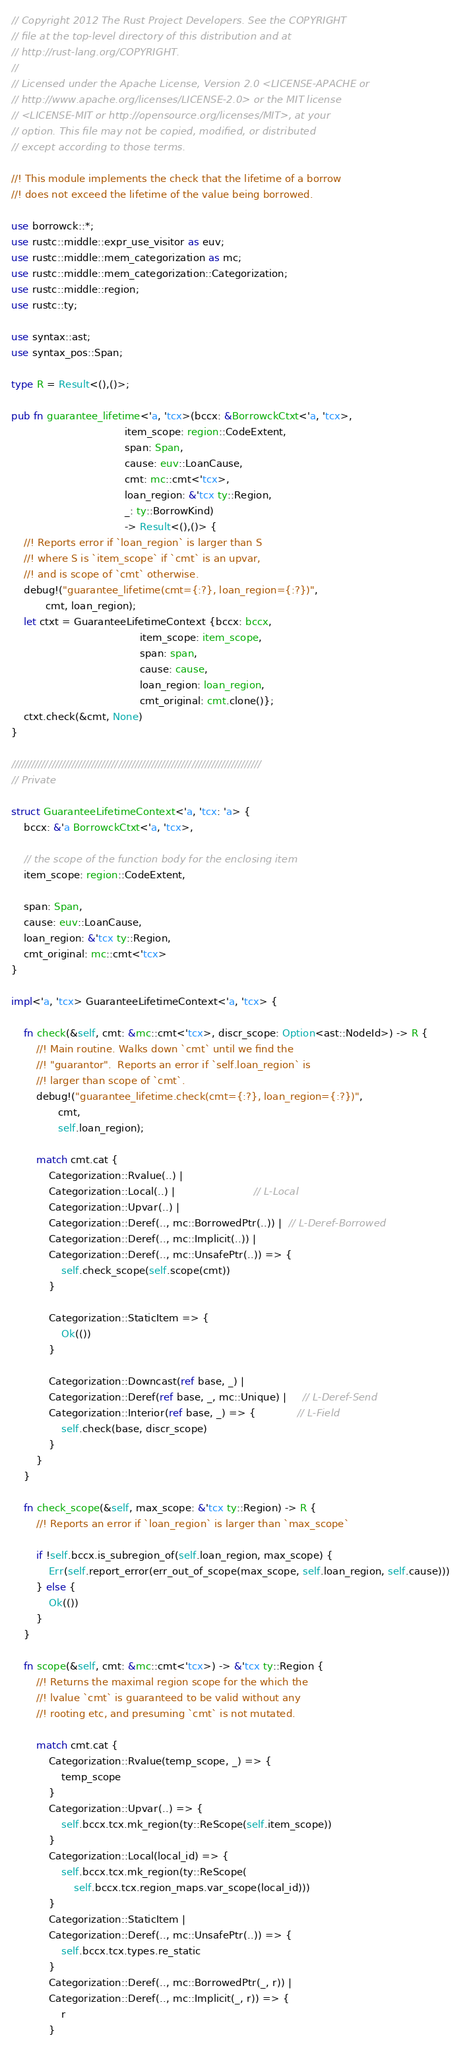<code> <loc_0><loc_0><loc_500><loc_500><_Rust_>// Copyright 2012 The Rust Project Developers. See the COPYRIGHT
// file at the top-level directory of this distribution and at
// http://rust-lang.org/COPYRIGHT.
//
// Licensed under the Apache License, Version 2.0 <LICENSE-APACHE or
// http://www.apache.org/licenses/LICENSE-2.0> or the MIT license
// <LICENSE-MIT or http://opensource.org/licenses/MIT>, at your
// option. This file may not be copied, modified, or distributed
// except according to those terms.

//! This module implements the check that the lifetime of a borrow
//! does not exceed the lifetime of the value being borrowed.

use borrowck::*;
use rustc::middle::expr_use_visitor as euv;
use rustc::middle::mem_categorization as mc;
use rustc::middle::mem_categorization::Categorization;
use rustc::middle::region;
use rustc::ty;

use syntax::ast;
use syntax_pos::Span;

type R = Result<(),()>;

pub fn guarantee_lifetime<'a, 'tcx>(bccx: &BorrowckCtxt<'a, 'tcx>,
                                    item_scope: region::CodeExtent,
                                    span: Span,
                                    cause: euv::LoanCause,
                                    cmt: mc::cmt<'tcx>,
                                    loan_region: &'tcx ty::Region,
                                    _: ty::BorrowKind)
                                    -> Result<(),()> {
    //! Reports error if `loan_region` is larger than S
    //! where S is `item_scope` if `cmt` is an upvar,
    //! and is scope of `cmt` otherwise.
    debug!("guarantee_lifetime(cmt={:?}, loan_region={:?})",
           cmt, loan_region);
    let ctxt = GuaranteeLifetimeContext {bccx: bccx,
                                         item_scope: item_scope,
                                         span: span,
                                         cause: cause,
                                         loan_region: loan_region,
                                         cmt_original: cmt.clone()};
    ctxt.check(&cmt, None)
}

///////////////////////////////////////////////////////////////////////////
// Private

struct GuaranteeLifetimeContext<'a, 'tcx: 'a> {
    bccx: &'a BorrowckCtxt<'a, 'tcx>,

    // the scope of the function body for the enclosing item
    item_scope: region::CodeExtent,

    span: Span,
    cause: euv::LoanCause,
    loan_region: &'tcx ty::Region,
    cmt_original: mc::cmt<'tcx>
}

impl<'a, 'tcx> GuaranteeLifetimeContext<'a, 'tcx> {

    fn check(&self, cmt: &mc::cmt<'tcx>, discr_scope: Option<ast::NodeId>) -> R {
        //! Main routine. Walks down `cmt` until we find the
        //! "guarantor".  Reports an error if `self.loan_region` is
        //! larger than scope of `cmt`.
        debug!("guarantee_lifetime.check(cmt={:?}, loan_region={:?})",
               cmt,
               self.loan_region);

        match cmt.cat {
            Categorization::Rvalue(..) |
            Categorization::Local(..) |                         // L-Local
            Categorization::Upvar(..) |
            Categorization::Deref(.., mc::BorrowedPtr(..)) |  // L-Deref-Borrowed
            Categorization::Deref(.., mc::Implicit(..)) |
            Categorization::Deref(.., mc::UnsafePtr(..)) => {
                self.check_scope(self.scope(cmt))
            }

            Categorization::StaticItem => {
                Ok(())
            }

            Categorization::Downcast(ref base, _) |
            Categorization::Deref(ref base, _, mc::Unique) |     // L-Deref-Send
            Categorization::Interior(ref base, _) => {             // L-Field
                self.check(base, discr_scope)
            }
        }
    }

    fn check_scope(&self, max_scope: &'tcx ty::Region) -> R {
        //! Reports an error if `loan_region` is larger than `max_scope`

        if !self.bccx.is_subregion_of(self.loan_region, max_scope) {
            Err(self.report_error(err_out_of_scope(max_scope, self.loan_region, self.cause)))
        } else {
            Ok(())
        }
    }

    fn scope(&self, cmt: &mc::cmt<'tcx>) -> &'tcx ty::Region {
        //! Returns the maximal region scope for the which the
        //! lvalue `cmt` is guaranteed to be valid without any
        //! rooting etc, and presuming `cmt` is not mutated.

        match cmt.cat {
            Categorization::Rvalue(temp_scope, _) => {
                temp_scope
            }
            Categorization::Upvar(..) => {
                self.bccx.tcx.mk_region(ty::ReScope(self.item_scope))
            }
            Categorization::Local(local_id) => {
                self.bccx.tcx.mk_region(ty::ReScope(
                    self.bccx.tcx.region_maps.var_scope(local_id)))
            }
            Categorization::StaticItem |
            Categorization::Deref(.., mc::UnsafePtr(..)) => {
                self.bccx.tcx.types.re_static
            }
            Categorization::Deref(.., mc::BorrowedPtr(_, r)) |
            Categorization::Deref(.., mc::Implicit(_, r)) => {
                r
            }</code> 